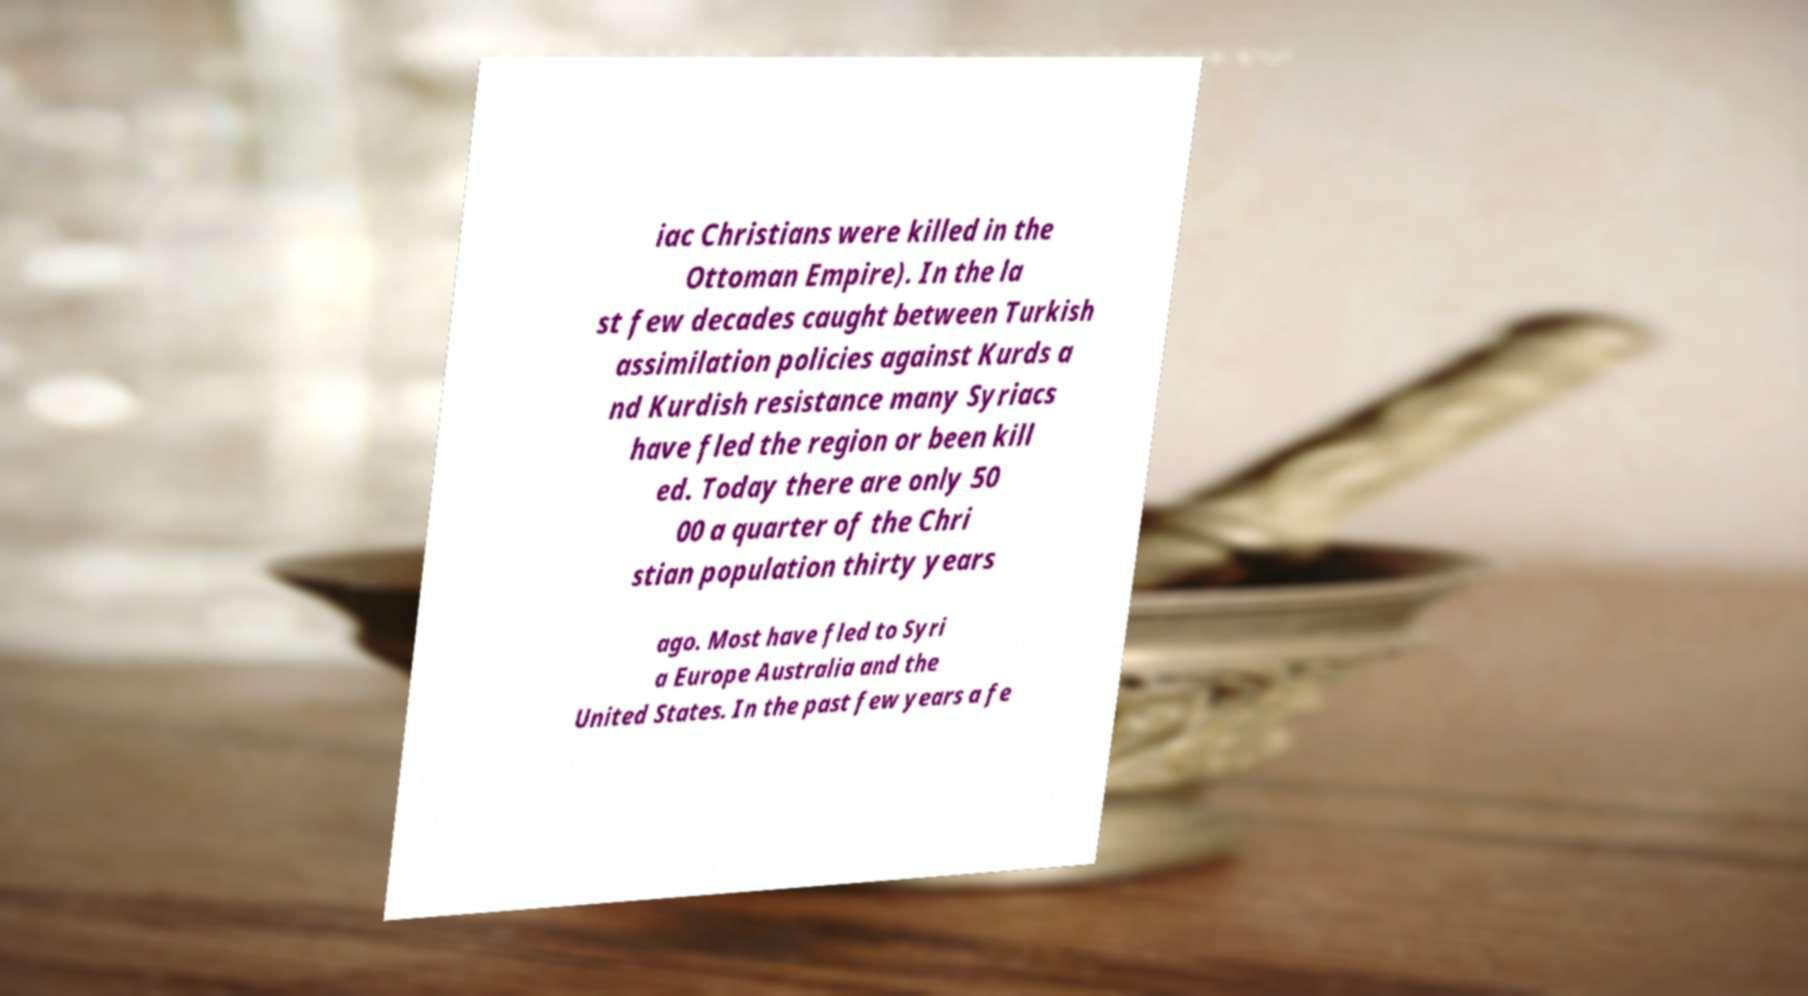I need the written content from this picture converted into text. Can you do that? iac Christians were killed in the Ottoman Empire). In the la st few decades caught between Turkish assimilation policies against Kurds a nd Kurdish resistance many Syriacs have fled the region or been kill ed. Today there are only 50 00 a quarter of the Chri stian population thirty years ago. Most have fled to Syri a Europe Australia and the United States. In the past few years a fe 